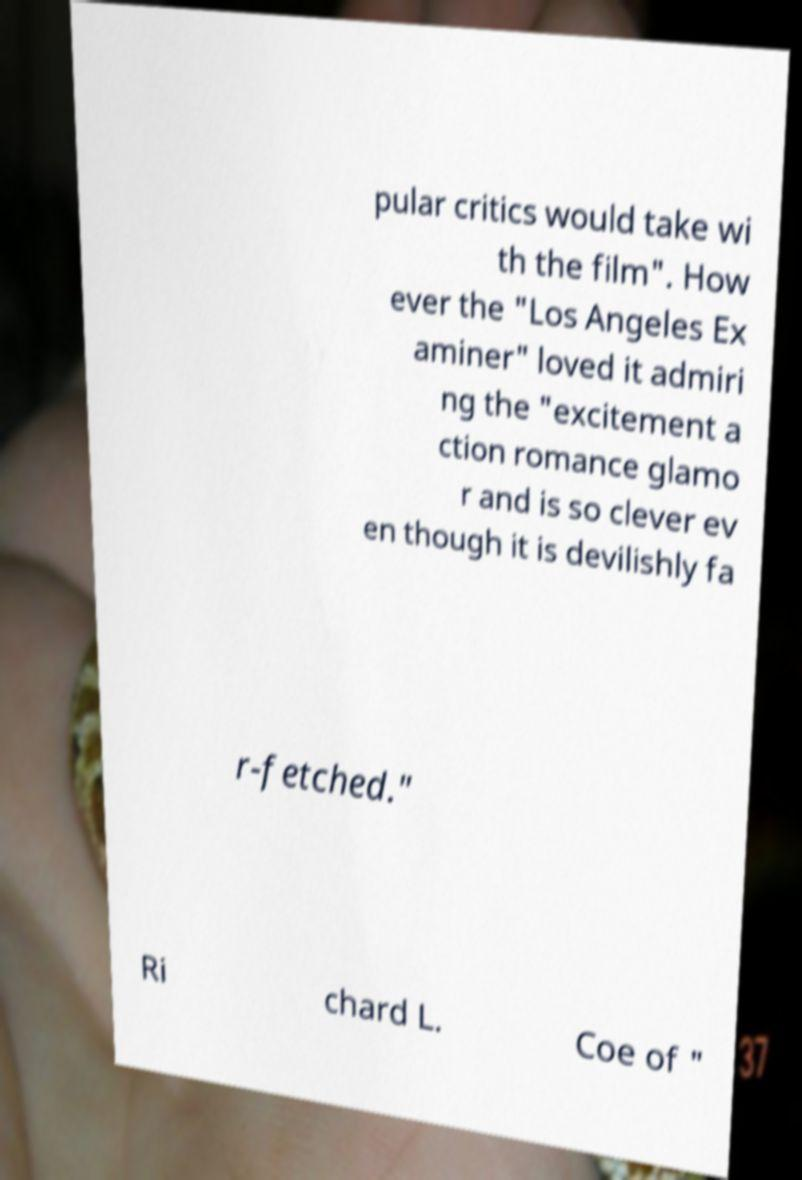I need the written content from this picture converted into text. Can you do that? pular critics would take wi th the film". How ever the "Los Angeles Ex aminer" loved it admiri ng the "excitement a ction romance glamo r and is so clever ev en though it is devilishly fa r-fetched." Ri chard L. Coe of " 